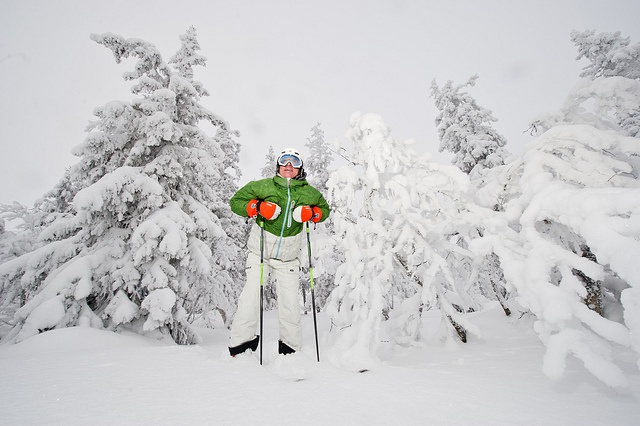Describe the objects in this image and their specific colors. I can see people in lightgray, darkgray, black, and darkgreen tones and skis in lightgray, darkgray, and gray tones in this image. 